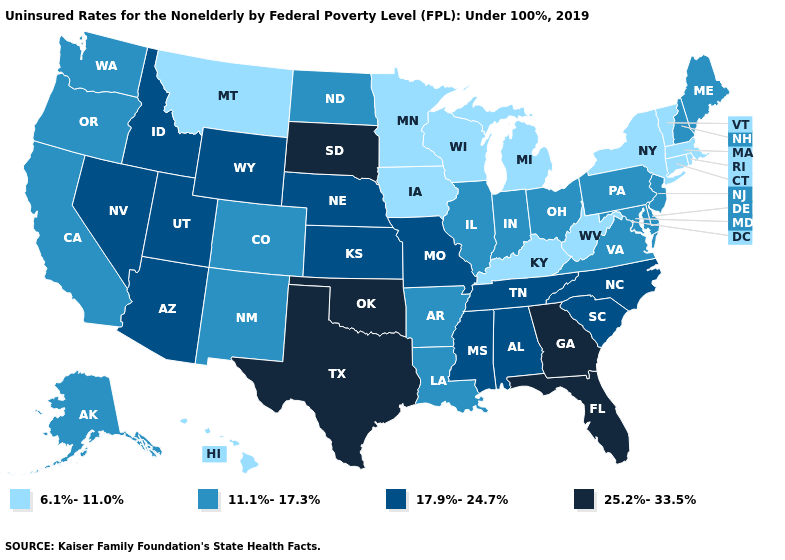Does the first symbol in the legend represent the smallest category?
Answer briefly. Yes. What is the value of Mississippi?
Give a very brief answer. 17.9%-24.7%. Among the states that border Virginia , which have the lowest value?
Be succinct. Kentucky, West Virginia. Name the states that have a value in the range 25.2%-33.5%?
Give a very brief answer. Florida, Georgia, Oklahoma, South Dakota, Texas. What is the highest value in states that border Texas?
Concise answer only. 25.2%-33.5%. Name the states that have a value in the range 25.2%-33.5%?
Short answer required. Florida, Georgia, Oklahoma, South Dakota, Texas. What is the value of Tennessee?
Quick response, please. 17.9%-24.7%. Does Arizona have the lowest value in the West?
Concise answer only. No. What is the value of Washington?
Be succinct. 11.1%-17.3%. What is the value of Oregon?
Give a very brief answer. 11.1%-17.3%. What is the value of New York?
Answer briefly. 6.1%-11.0%. What is the value of Alabama?
Answer briefly. 17.9%-24.7%. Among the states that border Ohio , which have the lowest value?
Write a very short answer. Kentucky, Michigan, West Virginia. Name the states that have a value in the range 25.2%-33.5%?
Give a very brief answer. Florida, Georgia, Oklahoma, South Dakota, Texas. 